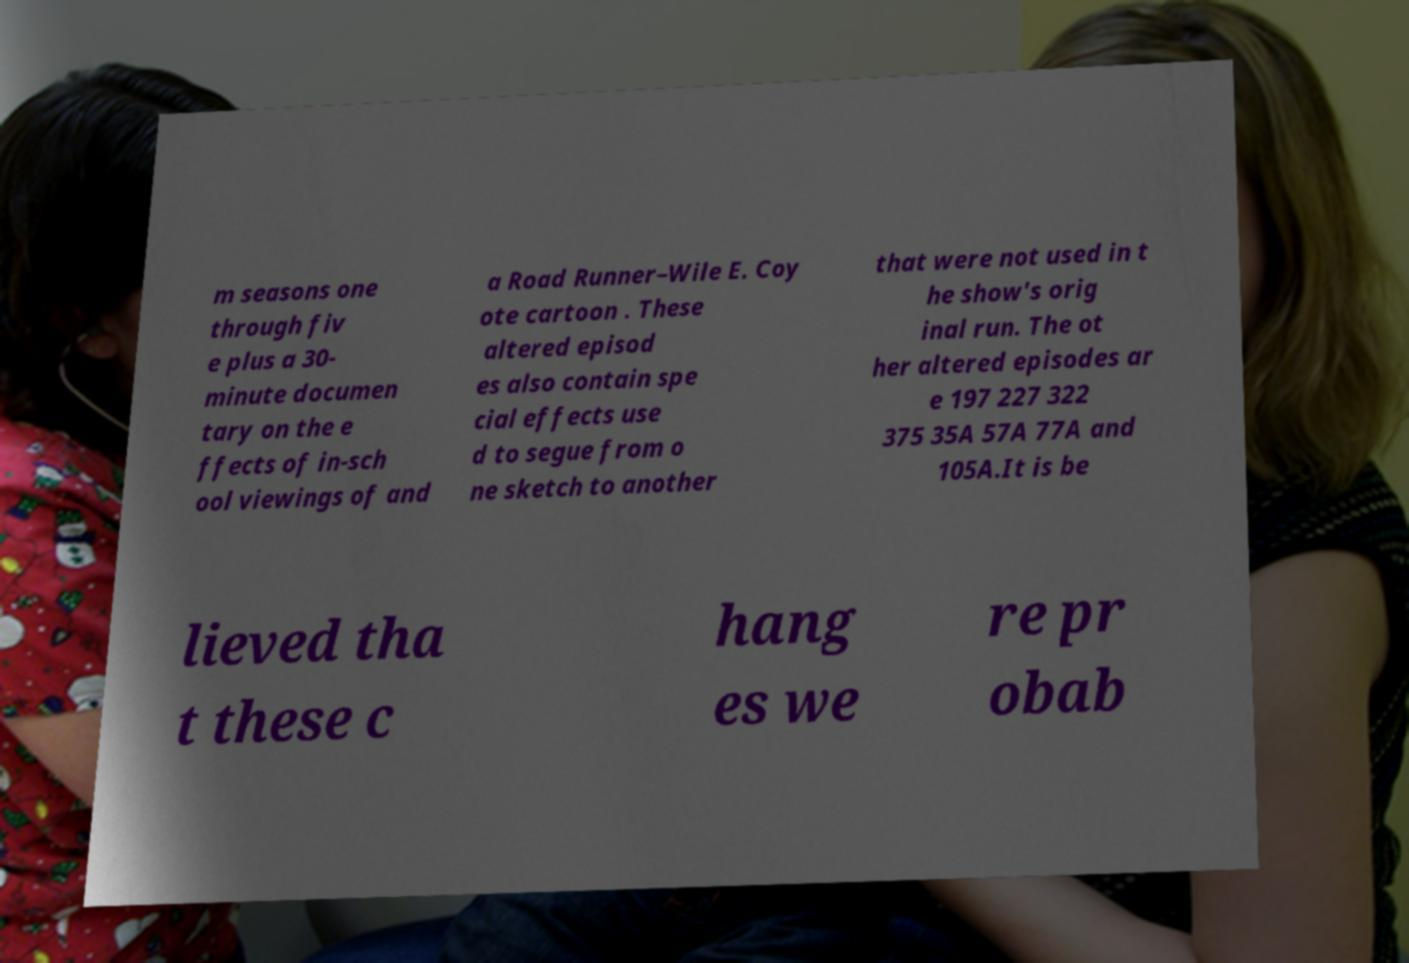Could you assist in decoding the text presented in this image and type it out clearly? m seasons one through fiv e plus a 30- minute documen tary on the e ffects of in-sch ool viewings of and a Road Runner–Wile E. Coy ote cartoon . These altered episod es also contain spe cial effects use d to segue from o ne sketch to another that were not used in t he show's orig inal run. The ot her altered episodes ar e 197 227 322 375 35A 57A 77A and 105A.It is be lieved tha t these c hang es we re pr obab 